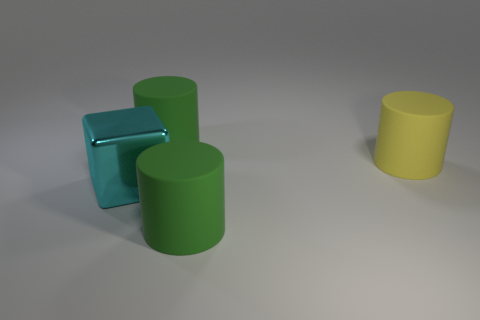There is a cube that is the same size as the yellow thing; what is its material?
Make the answer very short. Metal. How many objects are large green rubber objects behind the cyan block or green rubber objects that are behind the block?
Keep it short and to the point. 1. Is the number of big cylinders less than the number of large things?
Offer a terse response. Yes. What shape is the metal object that is the same size as the yellow rubber cylinder?
Offer a very short reply. Cube. What number of green rubber objects are there?
Provide a short and direct response. 2. How many big rubber cylinders are behind the metal thing and on the left side of the big yellow cylinder?
Offer a terse response. 1. What is the big yellow object made of?
Give a very brief answer. Rubber. Are there any cyan shiny things?
Give a very brief answer. Yes. The object that is in front of the big cyan object is what color?
Your response must be concise. Green. There is a green rubber cylinder in front of the matte cylinder that is behind the big yellow thing; what number of green things are left of it?
Your response must be concise. 1. 